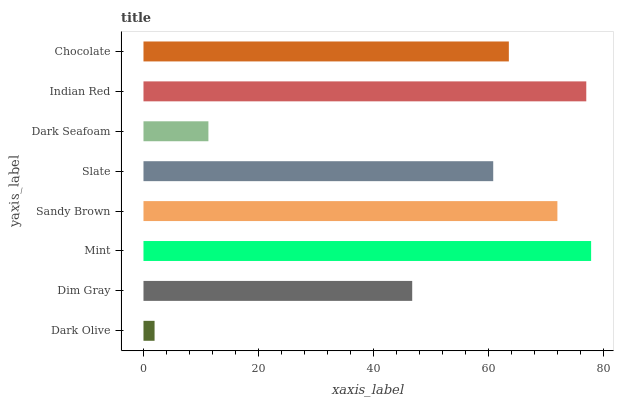Is Dark Olive the minimum?
Answer yes or no. Yes. Is Mint the maximum?
Answer yes or no. Yes. Is Dim Gray the minimum?
Answer yes or no. No. Is Dim Gray the maximum?
Answer yes or no. No. Is Dim Gray greater than Dark Olive?
Answer yes or no. Yes. Is Dark Olive less than Dim Gray?
Answer yes or no. Yes. Is Dark Olive greater than Dim Gray?
Answer yes or no. No. Is Dim Gray less than Dark Olive?
Answer yes or no. No. Is Chocolate the high median?
Answer yes or no. Yes. Is Slate the low median?
Answer yes or no. Yes. Is Dim Gray the high median?
Answer yes or no. No. Is Mint the low median?
Answer yes or no. No. 